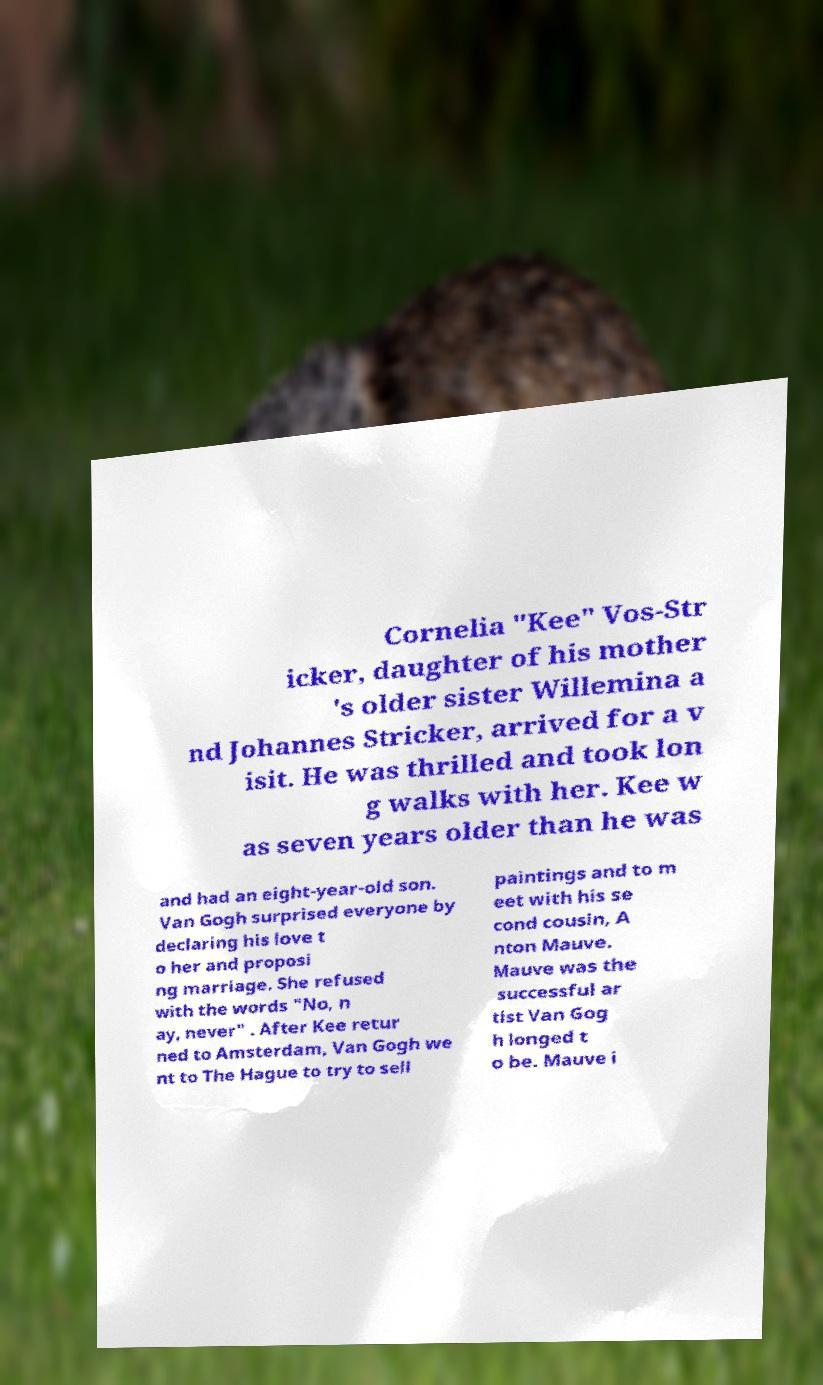What messages or text are displayed in this image? I need them in a readable, typed format. Cornelia "Kee" Vos-Str icker, daughter of his mother 's older sister Willemina a nd Johannes Stricker, arrived for a v isit. He was thrilled and took lon g walks with her. Kee w as seven years older than he was and had an eight-year-old son. Van Gogh surprised everyone by declaring his love t o her and proposi ng marriage. She refused with the words "No, n ay, never" . After Kee retur ned to Amsterdam, Van Gogh we nt to The Hague to try to sell paintings and to m eet with his se cond cousin, A nton Mauve. Mauve was the successful ar tist Van Gog h longed t o be. Mauve i 